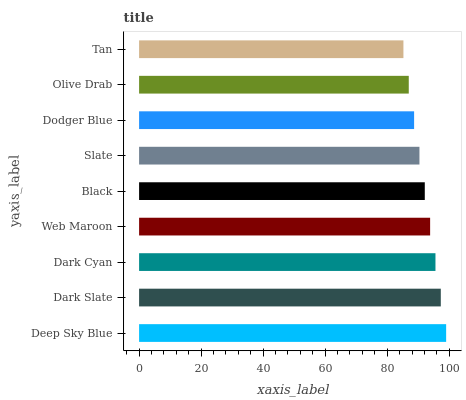Is Tan the minimum?
Answer yes or no. Yes. Is Deep Sky Blue the maximum?
Answer yes or no. Yes. Is Dark Slate the minimum?
Answer yes or no. No. Is Dark Slate the maximum?
Answer yes or no. No. Is Deep Sky Blue greater than Dark Slate?
Answer yes or no. Yes. Is Dark Slate less than Deep Sky Blue?
Answer yes or no. Yes. Is Dark Slate greater than Deep Sky Blue?
Answer yes or no. No. Is Deep Sky Blue less than Dark Slate?
Answer yes or no. No. Is Black the high median?
Answer yes or no. Yes. Is Black the low median?
Answer yes or no. Yes. Is Dark Slate the high median?
Answer yes or no. No. Is Deep Sky Blue the low median?
Answer yes or no. No. 